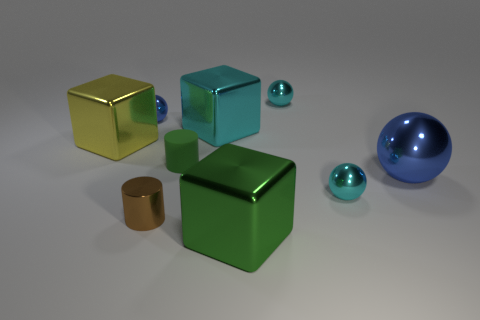Subtract all red spheres. Subtract all blue cubes. How many spheres are left? 4 Add 1 large green metallic things. How many objects exist? 10 Subtract all cylinders. How many objects are left? 7 Add 6 small rubber things. How many small rubber things are left? 7 Add 3 tiny brown objects. How many tiny brown objects exist? 4 Subtract 0 gray blocks. How many objects are left? 9 Subtract all large brown matte cubes. Subtract all tiny green rubber cylinders. How many objects are left? 8 